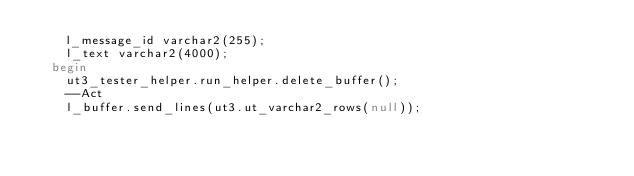<code> <loc_0><loc_0><loc_500><loc_500><_SQL_>    l_message_id varchar2(255);
    l_text varchar2(4000);
  begin
    ut3_tester_helper.run_helper.delete_buffer();
    --Act
    l_buffer.send_lines(ut3.ut_varchar2_rows(null));</code> 